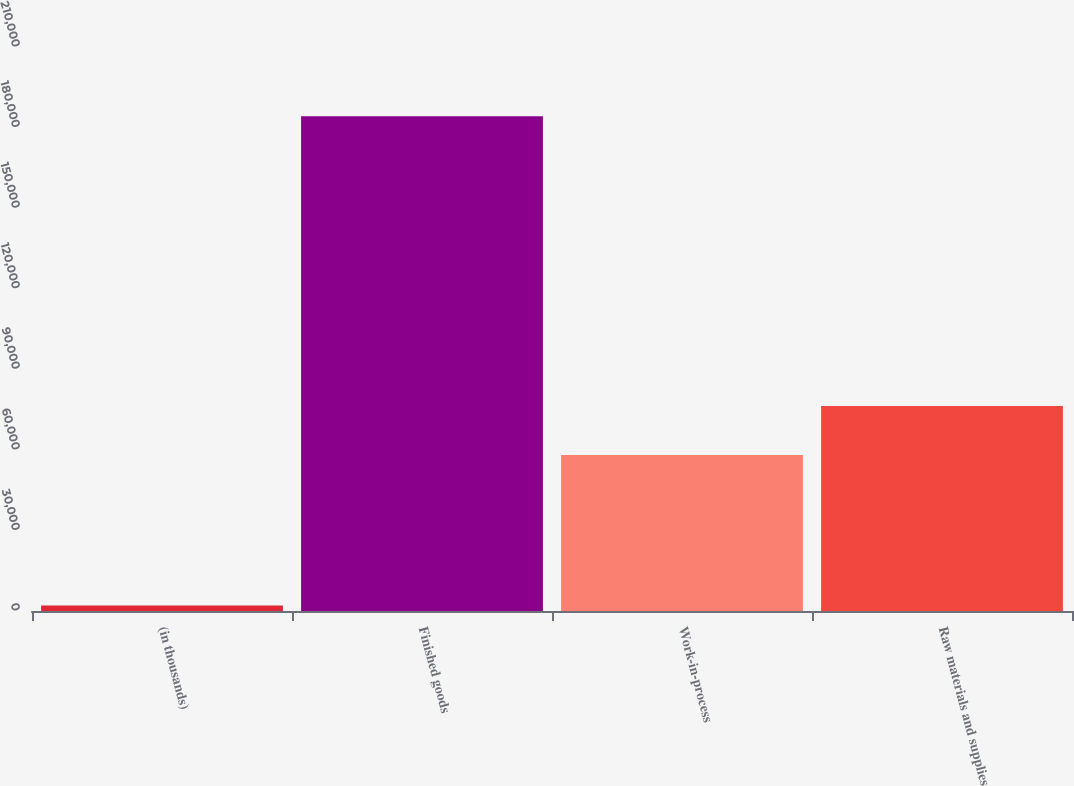Convert chart. <chart><loc_0><loc_0><loc_500><loc_500><bar_chart><fcel>(in thousands)<fcel>Finished goods<fcel>Work-in-process<fcel>Raw materials and supplies<nl><fcel>2008<fcel>184226<fcel>58123<fcel>76344.8<nl></chart> 